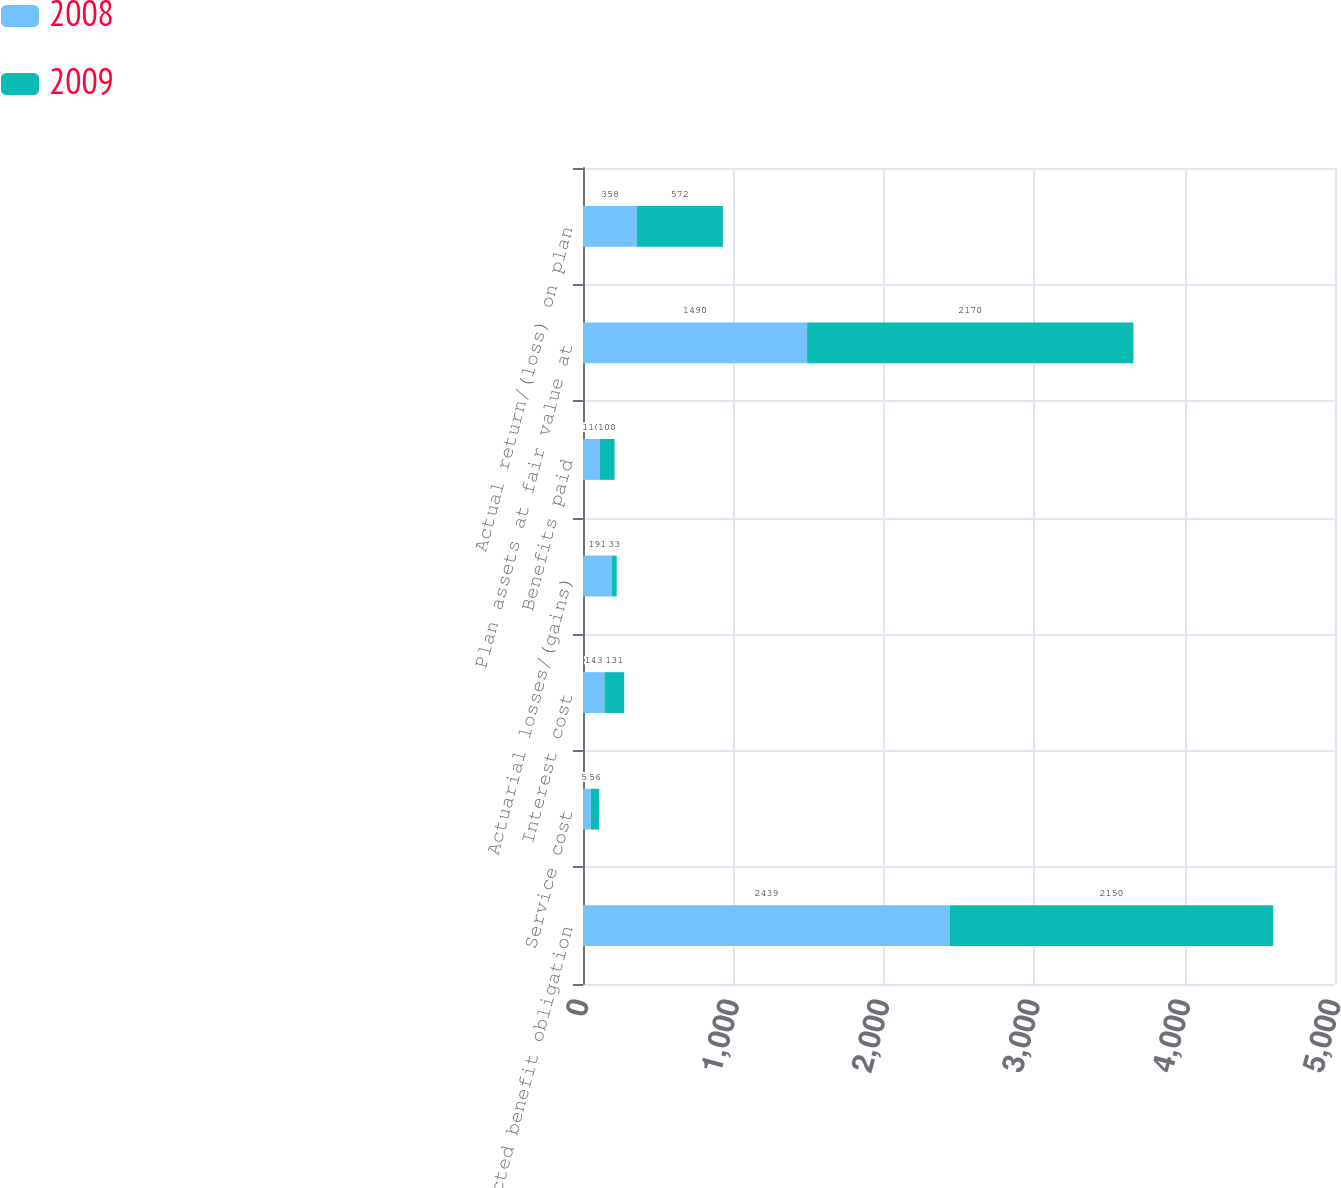<chart> <loc_0><loc_0><loc_500><loc_500><stacked_bar_chart><ecel><fcel>Projected benefit obligation<fcel>Service cost<fcel>Interest cost<fcel>Actuarial losses/(gains)<fcel>Benefits paid<fcel>Plan assets at fair value at<fcel>Actual return/(loss) on plan<nl><fcel>2008<fcel>2439<fcel>52<fcel>143<fcel>191<fcel>110<fcel>1490<fcel>358<nl><fcel>2009<fcel>2150<fcel>56<fcel>131<fcel>33<fcel>100<fcel>2170<fcel>572<nl></chart> 